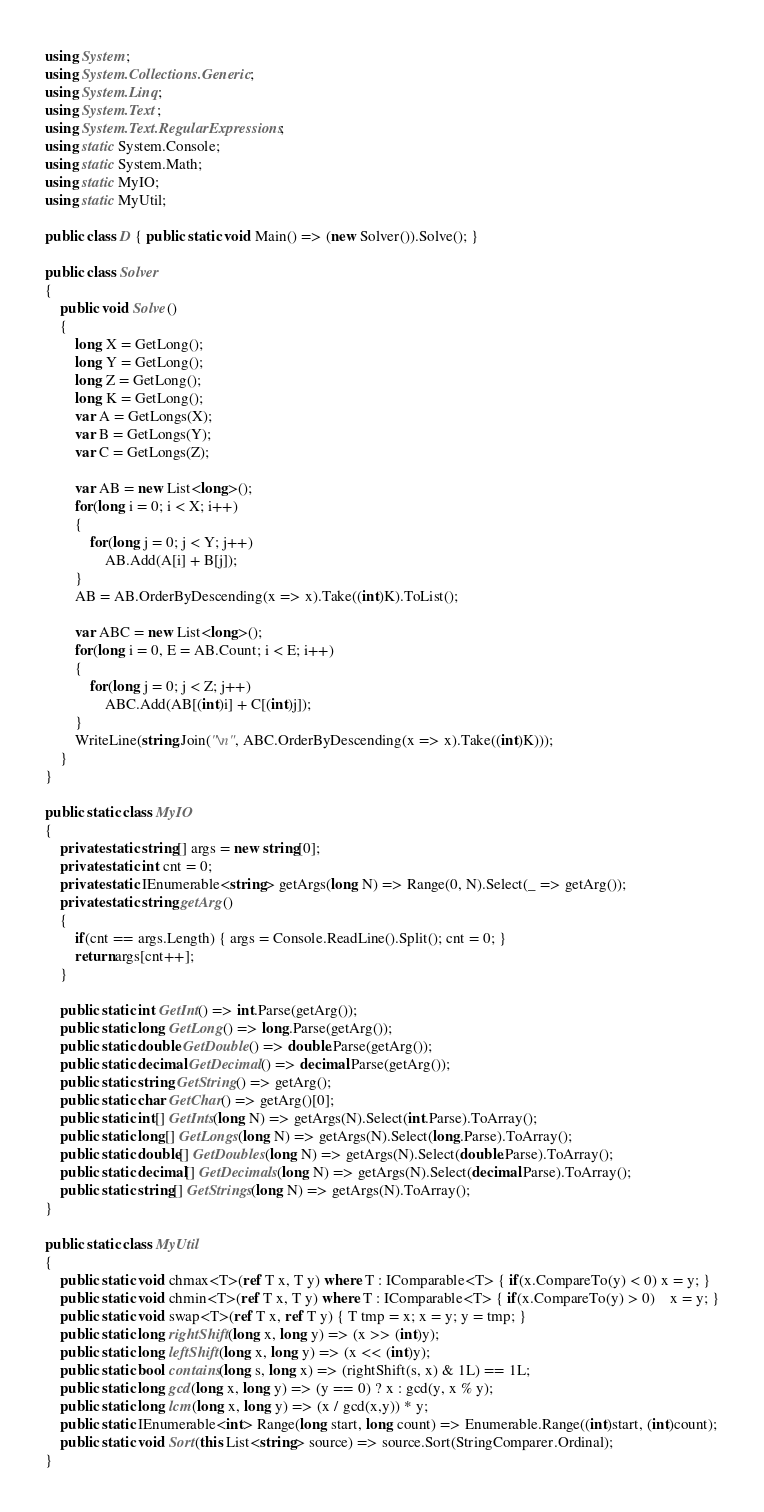<code> <loc_0><loc_0><loc_500><loc_500><_C#_>using System;
using System.Collections.Generic;
using System.Linq;
using System.Text;
using System.Text.RegularExpressions;
using static System.Console;
using static System.Math;
using static MyIO;
using static MyUtil;

public class D { public static void Main() => (new Solver()).Solve(); }

public class Solver
{
	public void Solve()
	{
		long X = GetLong();
		long Y = GetLong();
		long Z = GetLong();
		long K = GetLong();
		var A = GetLongs(X);
		var B = GetLongs(Y);
		var C = GetLongs(Z);

		var AB = new List<long>();
		for(long i = 0; i < X; i++)
		{
			for(long j = 0; j < Y; j++)
				AB.Add(A[i] + B[j]);
		}
		AB = AB.OrderByDescending(x => x).Take((int)K).ToList();

		var ABC = new List<long>();
		for(long i = 0, E = AB.Count; i < E; i++)
		{
			for(long j = 0; j < Z; j++)
				ABC.Add(AB[(int)i] + C[(int)j]);
		}
		WriteLine(string.Join("\n", ABC.OrderByDescending(x => x).Take((int)K)));
	}
}

public static class MyIO
{
	private static string[] args = new string[0];
	private static int cnt = 0;
	private static IEnumerable<string> getArgs(long N) => Range(0, N).Select(_ => getArg());
	private static string getArg()
	{
		if(cnt == args.Length) { args = Console.ReadLine().Split(); cnt = 0; }
		return args[cnt++];
	}

	public static int GetInt() => int.Parse(getArg());
	public static long GetLong() => long.Parse(getArg());
	public static double GetDouble() => double.Parse(getArg());
	public static decimal GetDecimal() => decimal.Parse(getArg());
	public static string GetString() => getArg();
	public static char GetChar() => getArg()[0];
	public static int[] GetInts(long N) => getArgs(N).Select(int.Parse).ToArray();
	public static long[] GetLongs(long N) => getArgs(N).Select(long.Parse).ToArray();
	public static double[] GetDoubles(long N) => getArgs(N).Select(double.Parse).ToArray();
	public static decimal[] GetDecimals(long N) => getArgs(N).Select(decimal.Parse).ToArray();
	public static string[] GetStrings(long N) => getArgs(N).ToArray();
}

public static class MyUtil
{
	public static void chmax<T>(ref T x, T y) where T : IComparable<T> { if(x.CompareTo(y) < 0) x = y; }
	public static void chmin<T>(ref T x, T y) where T : IComparable<T> { if(x.CompareTo(y) > 0)	x = y; }
	public static void swap<T>(ref T x, ref T y) { T tmp = x; x = y; y = tmp; }
	public static long rightShift(long x, long y) => (x >> (int)y);
	public static long leftShift(long x, long y) => (x << (int)y);
	public static bool contains(long s, long x) => (rightShift(s, x) & 1L) == 1L;
	public static long gcd(long x, long y) => (y == 0) ? x : gcd(y, x % y);
	public static long lcm(long x, long y) => (x / gcd(x,y)) * y;	
	public static IEnumerable<int> Range(long start, long count) => Enumerable.Range((int)start, (int)count);
	public static void Sort(this List<string> source) => source.Sort(StringComparer.Ordinal);
}
</code> 